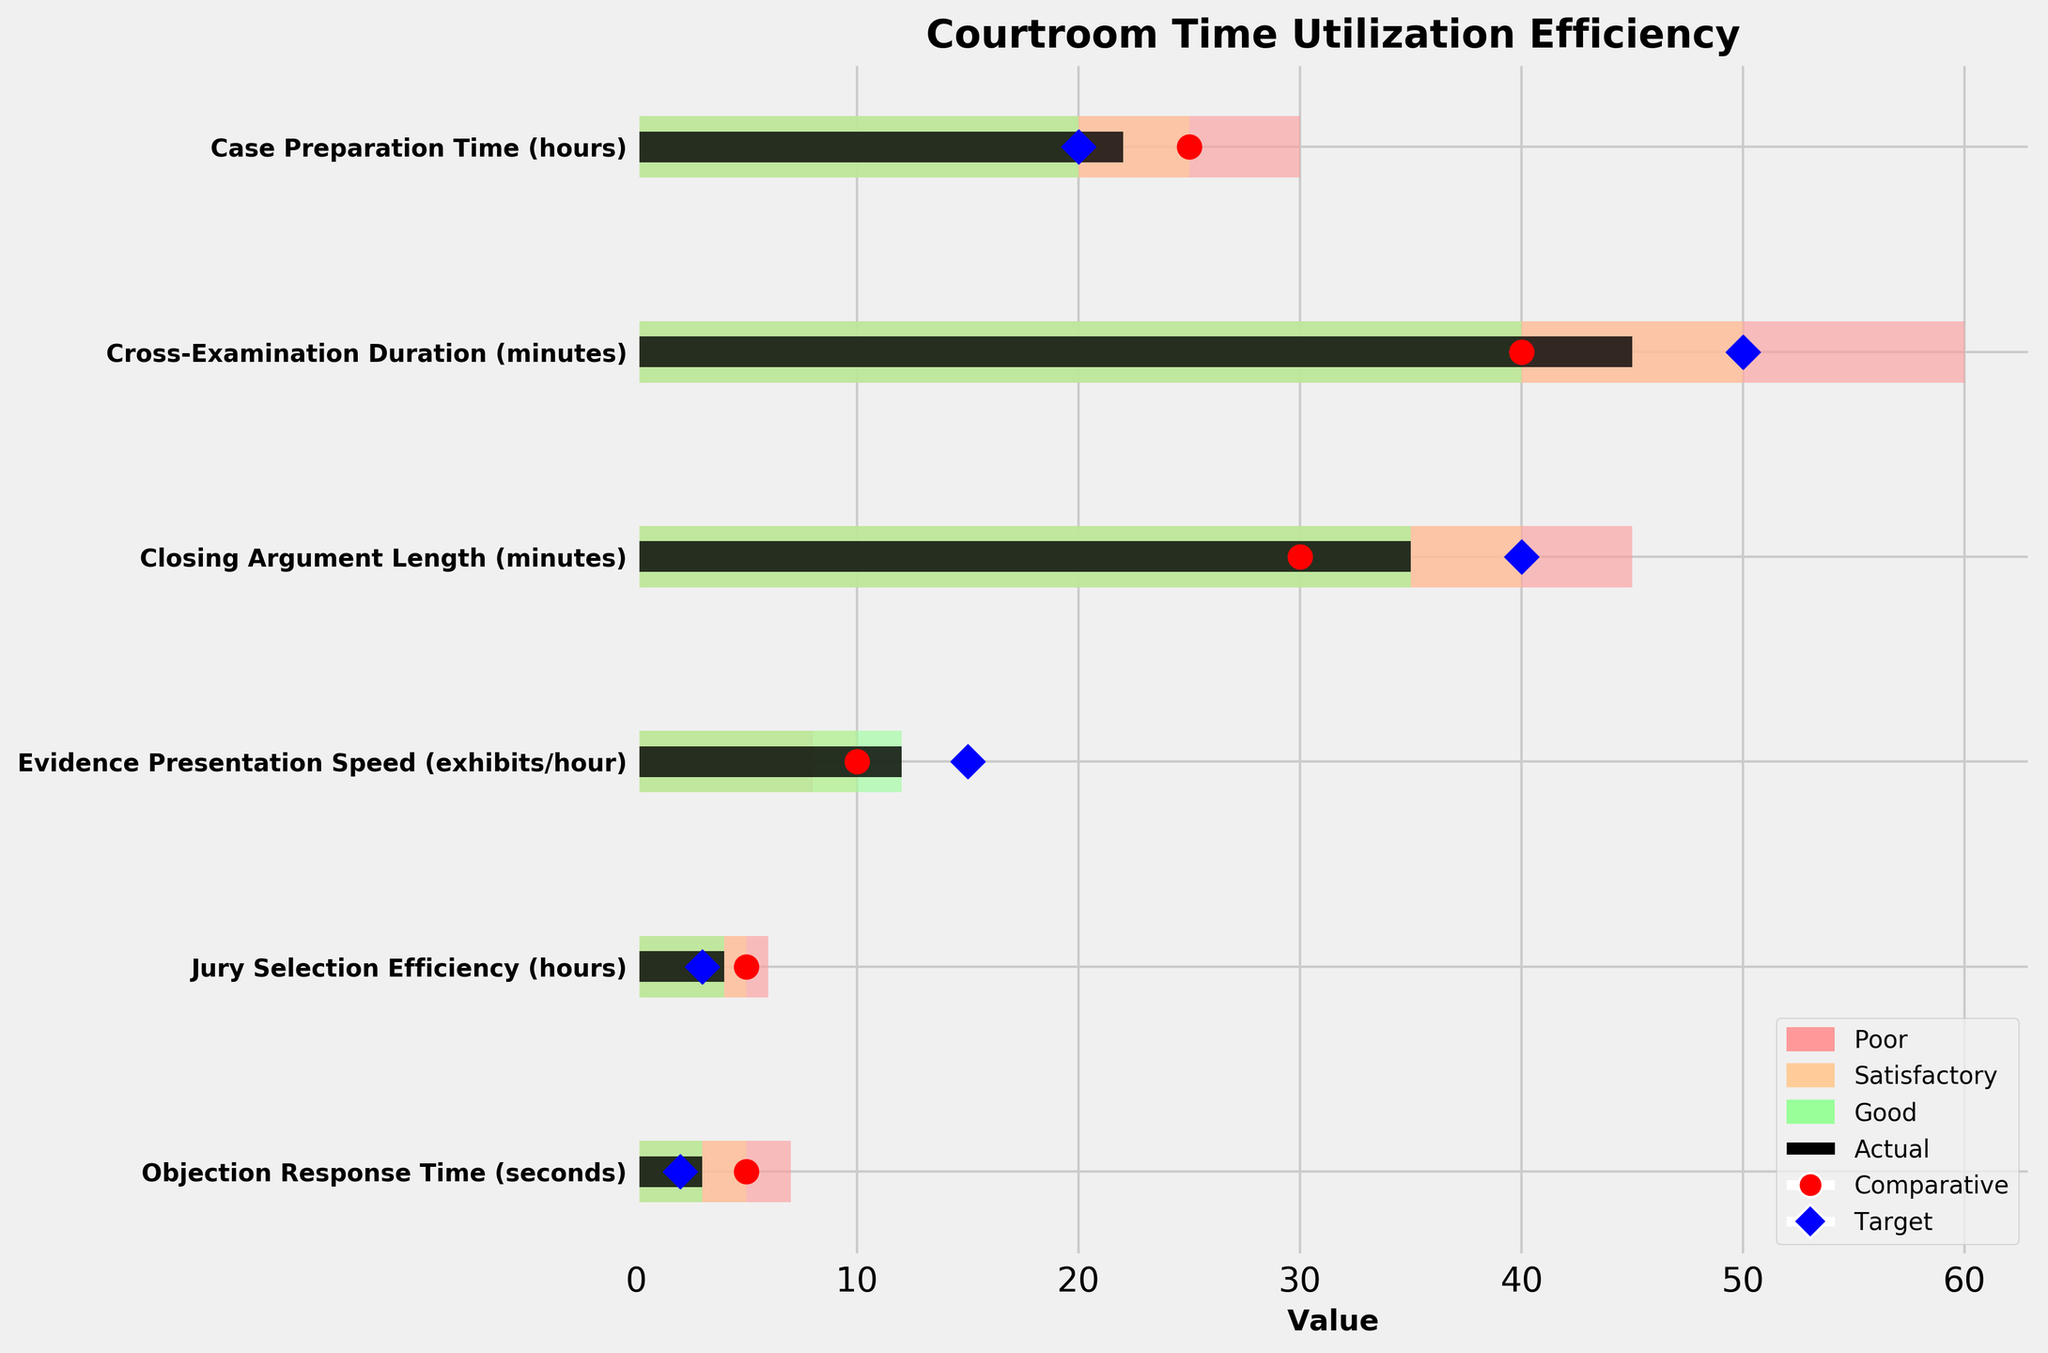What is the title of the chart? The title is displayed prominently at the top of the chart in larger and bold text. It provides a summary of what the chart represents.
Answer: Courtroom Time Utilization Efficiency How many metrics are displayed in the chart? Each row represents a metric; count the number of rows to get the total number of metrics.
Answer: Six Which metric has the highest actual value? The actual values are represented by black horizontal bars. Identify the longest black bar and refer to the corresponding metric.
Answer: Case Preparation Time What color is used to indicate a 'Good' range in the chart? The 'Good' range is indicated by a specific color. Look at the legend to identify the corresponding color.
Answer: Light green Which metric has the largest difference between the actual value and the target value? Subtract the target value from the actual value for each metric and identify the metric with the largest difference.
Answer: Objection Response Time What is the comparative value for Cross-Examination Duration? Identify the red circular marker on the line corresponding to Cross-Examination Duration and read its value.
Answer: 40 minutes Is the actual Jury Selection Efficiency above or below the target? Compare the black bar for Jury Selection Efficiency to the blue diamond marker (target).
Answer: Above Which metric's actual value falls within the 'Poor' range? Look for metrics where the black bar falls within the range indicated by the color for 'Poor' (light red).
Answer: Cross-Examination Duration For Closing Argument Length, is the actual value closer to the target or the comparative value? Compare the black bar's length for actual value to the positions of the blue diamond (target) and the red circle (comparative) to see which is closer.
Answer: Closer to comparative Which metrics have their actual values better than satisfactory? Locate the black bars that fall within or better than the 'Satisfactory' (orange) range for each metric.
Answer: Case Preparation Time, Evidence Presentation Speed 